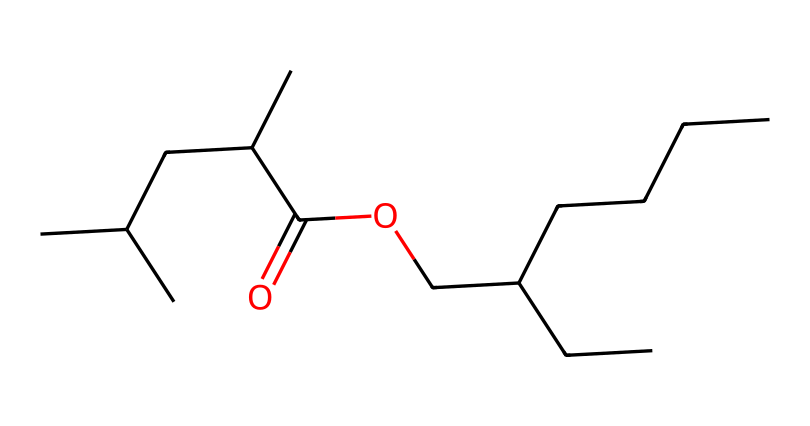How many carbon atoms are in this chemical structure? To determine the number of carbon atoms, we count the 'C' characters in the SMILES representation. The structure contains 13 carbon atoms.
Answer: 13 What is the functional group present in this chemical? By analyzing the structure, we identify the presence of a carboxyl group (-COOH), which is indicated by the part of the structure that contains both a carbonyl (C=O) and a hydroxyl group (-OH).
Answer: carboxyl How many oxygen atoms are in this structure? We locate the 'O' characters in the SMILES notation. The structure has 2 oxygen atoms: one in the carboxyl group and one in the ester linkage.
Answer: 2 Is this chemical likely to be a solid or a liquid at room temperature? The presence of multiple carbon atoms and the functional group characteristics suggest that this chemical is a low molecular weight organic compound likely to be a liquid at room temperature due to its flammability and structure.
Answer: liquid What type of reaction might this chemical undergo when heated? Given its structure and the presence of a carboxyl group, this chemical can undergo esterification or combustion when heated, leading to further breakdown products, potentially producing carbon dioxide and water.
Answer: combustion Does this chemical structure indicate any flammable properties? The presence of long carbon chains and functional groups typical of esters and acids suggests that this chemical has a significant risk of being flammable, as organic compounds with such structures are known to ignite easily.
Answer: yes 